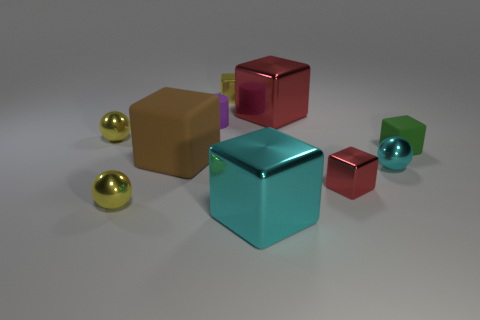Is the big rubber block the same color as the small cylinder?
Provide a short and direct response. No. Are there more cyan objects than small brown cylinders?
Give a very brief answer. Yes. How many other objects are the same color as the cylinder?
Offer a terse response. 0. What number of tiny green matte cubes are left of the yellow metal thing in front of the brown thing?
Provide a short and direct response. 0. Are there any big red shiny things to the right of the tiny red object?
Your response must be concise. No. What is the shape of the small rubber thing on the left side of the metal cube that is behind the large red shiny object?
Provide a succinct answer. Cylinder. Is the number of tiny metallic things behind the small cylinder less than the number of yellow things that are in front of the large red thing?
Provide a short and direct response. Yes. What color is the small rubber thing that is the same shape as the small red metal object?
Provide a short and direct response. Green. How many large cubes are both left of the big red metal object and behind the small cyan metallic object?
Make the answer very short. 1. Are there more green matte cubes in front of the brown matte cube than matte cubes that are to the right of the tiny red metal cube?
Your answer should be compact. No. 